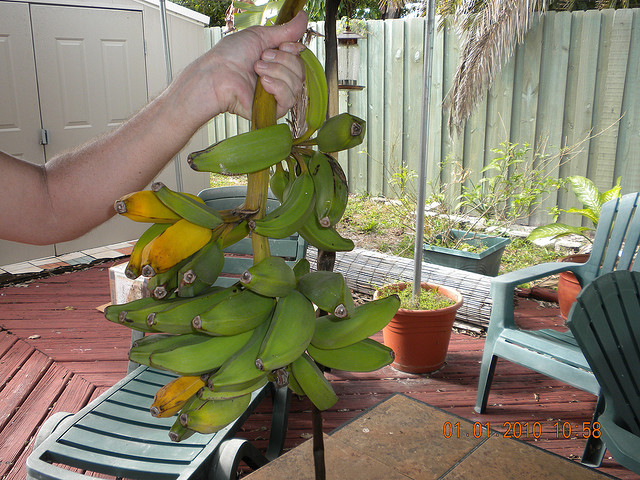Please transcribe the text information in this image. 01 01 2010 10 58 